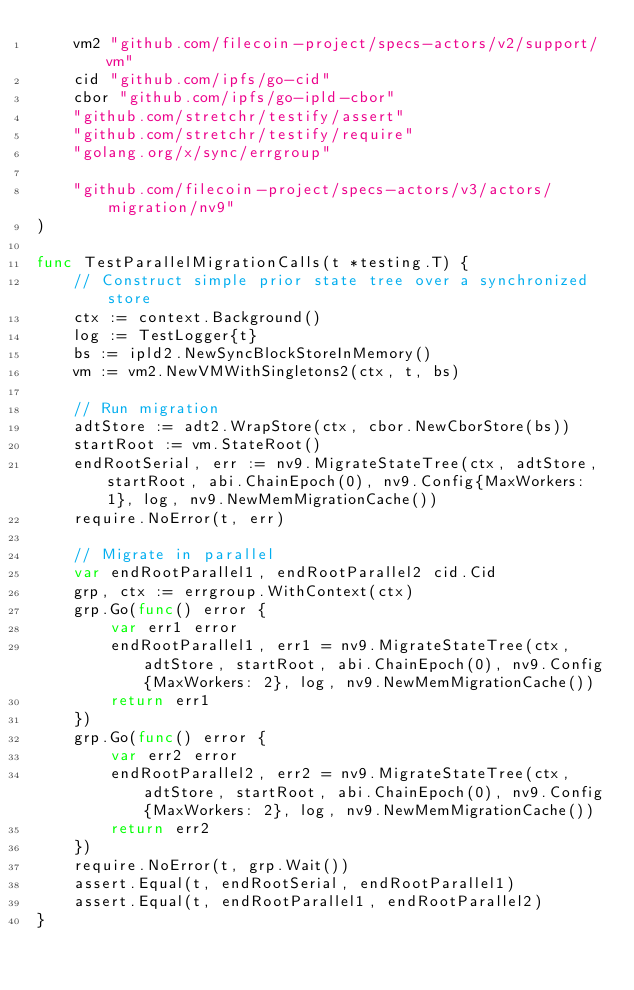Convert code to text. <code><loc_0><loc_0><loc_500><loc_500><_Go_>	vm2 "github.com/filecoin-project/specs-actors/v2/support/vm"
	cid "github.com/ipfs/go-cid"
	cbor "github.com/ipfs/go-ipld-cbor"
	"github.com/stretchr/testify/assert"
	"github.com/stretchr/testify/require"
	"golang.org/x/sync/errgroup"

	"github.com/filecoin-project/specs-actors/v3/actors/migration/nv9"
)

func TestParallelMigrationCalls(t *testing.T) {
	// Construct simple prior state tree over a synchronized store
	ctx := context.Background()
	log := TestLogger{t}
	bs := ipld2.NewSyncBlockStoreInMemory()
	vm := vm2.NewVMWithSingletons2(ctx, t, bs)

	// Run migration
	adtStore := adt2.WrapStore(ctx, cbor.NewCborStore(bs))
	startRoot := vm.StateRoot()
	endRootSerial, err := nv9.MigrateStateTree(ctx, adtStore, startRoot, abi.ChainEpoch(0), nv9.Config{MaxWorkers: 1}, log, nv9.NewMemMigrationCache())
	require.NoError(t, err)

	// Migrate in parallel
	var endRootParallel1, endRootParallel2 cid.Cid
	grp, ctx := errgroup.WithContext(ctx)
	grp.Go(func() error {
		var err1 error
		endRootParallel1, err1 = nv9.MigrateStateTree(ctx, adtStore, startRoot, abi.ChainEpoch(0), nv9.Config{MaxWorkers: 2}, log, nv9.NewMemMigrationCache())
		return err1
	})
	grp.Go(func() error {
		var err2 error
		endRootParallel2, err2 = nv9.MigrateStateTree(ctx, adtStore, startRoot, abi.ChainEpoch(0), nv9.Config{MaxWorkers: 2}, log, nv9.NewMemMigrationCache())
		return err2
	})
	require.NoError(t, grp.Wait())
	assert.Equal(t, endRootSerial, endRootParallel1)
	assert.Equal(t, endRootParallel1, endRootParallel2)
}
</code> 